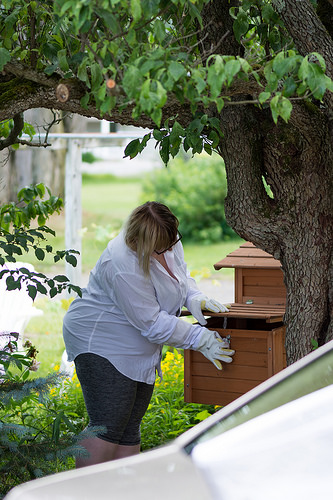<image>
Is the lady in the tree? No. The lady is not contained within the tree. These objects have a different spatial relationship. 